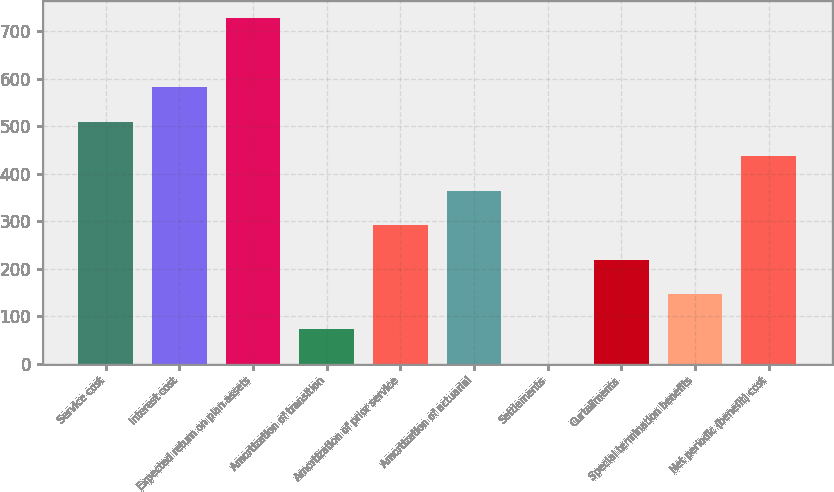Convert chart. <chart><loc_0><loc_0><loc_500><loc_500><bar_chart><fcel>Service cost<fcel>Interest cost<fcel>Expected return on plan assets<fcel>Amortization of transition<fcel>Amortization of prior service<fcel>Amortization of actuarial<fcel>Settlements<fcel>Curtailments<fcel>Special termination benefits<fcel>Net periodic (benefit) cost<nl><fcel>509.7<fcel>582.46<fcel>728<fcel>73.14<fcel>291.42<fcel>364.18<fcel>0.38<fcel>218.66<fcel>145.9<fcel>436.94<nl></chart> 